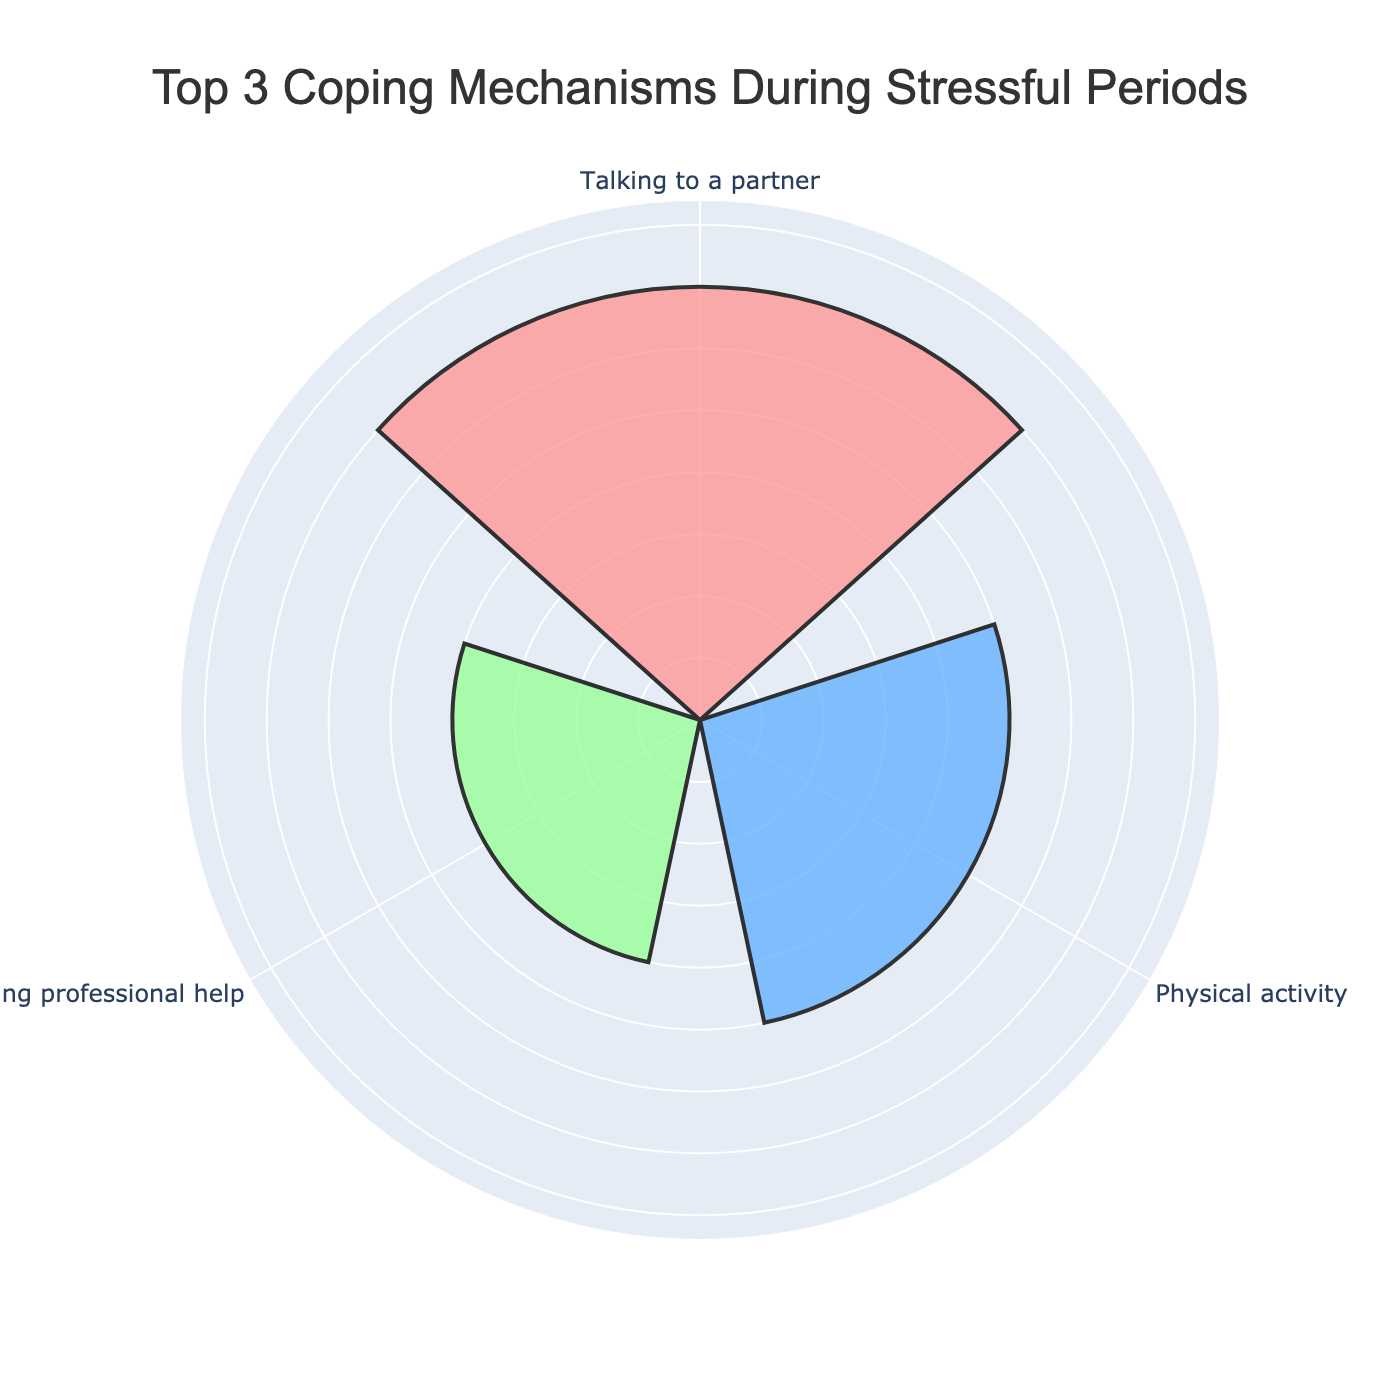What's the title of the figure? The title is usually found at the top of the figure. Reading it provides context for the content being displayed.
Answer: Top 3 Coping Mechanisms During Stressful Periods What are the three coping mechanisms displayed in the figure? The three coping mechanisms are labeled around the rose chart's perimeter, which identifies each segment.
Answer: Talking to a partner, Physical activity, Seeking professional help Which coping mechanism has the highest value? By reading the value labels or visually comparing the lengths of the segments, we can identify the coping mechanism with the highest value.
Answer: Talking to a partner Compare the values of 'Physical activity' and 'Seeking professional help'. By examining the labels or segments' lengths, we can see which is larger and by how much.
Answer: Physical activity is larger (25 vs. 20) What’s the combined value of 'Physical activity' and 'Seeking professional help'? Adding the values for 'Physical activity' and 'Seeking professional help' together gives the total. The values are 25 and 20 respectively, so 25 + 20 = 45.
Answer: 45 How does the value of 'Talking to a partner' compare to the sum of 'Physical activity' and 'Seeking professional help'? First, find the sum of 'Physical activity' and 'Seeking professional help' (25 + 20 = 45), then compare it with 'Talking to a partner' (35).
Answer: It’s smaller (35 vs. 45) What percentage of the total do all three top coping mechanisms represent individually? Calculate the total of the top 3 values (35 + 25 + 20 = 80) and then find each category's percentage: 'Talking to a partner' (35/80 ≈ 43.75%), 'Physical activity' (25/80 ≈ 31.25%), 'Seeking professional help' (20/80 = 25%).
Answer: Talking to a partner: 43.75%, Physical activity: 31.25%, Seeking professional help: 25% Which color represents the 'Physical activity' segment? Observing the color of the segment labeled 'Physical activity', we can see that it is blue.
Answer: Blue How many categories are excluded from this top 3 chart? The original data included four categories. Since three are displayed, only one is excluded.
Answer: 1 (Meditation) Are the radial ticks visible on the rose chart? By looking at the radial axis of the rose chart, we can see if tick marks are present or not.
Answer: No 